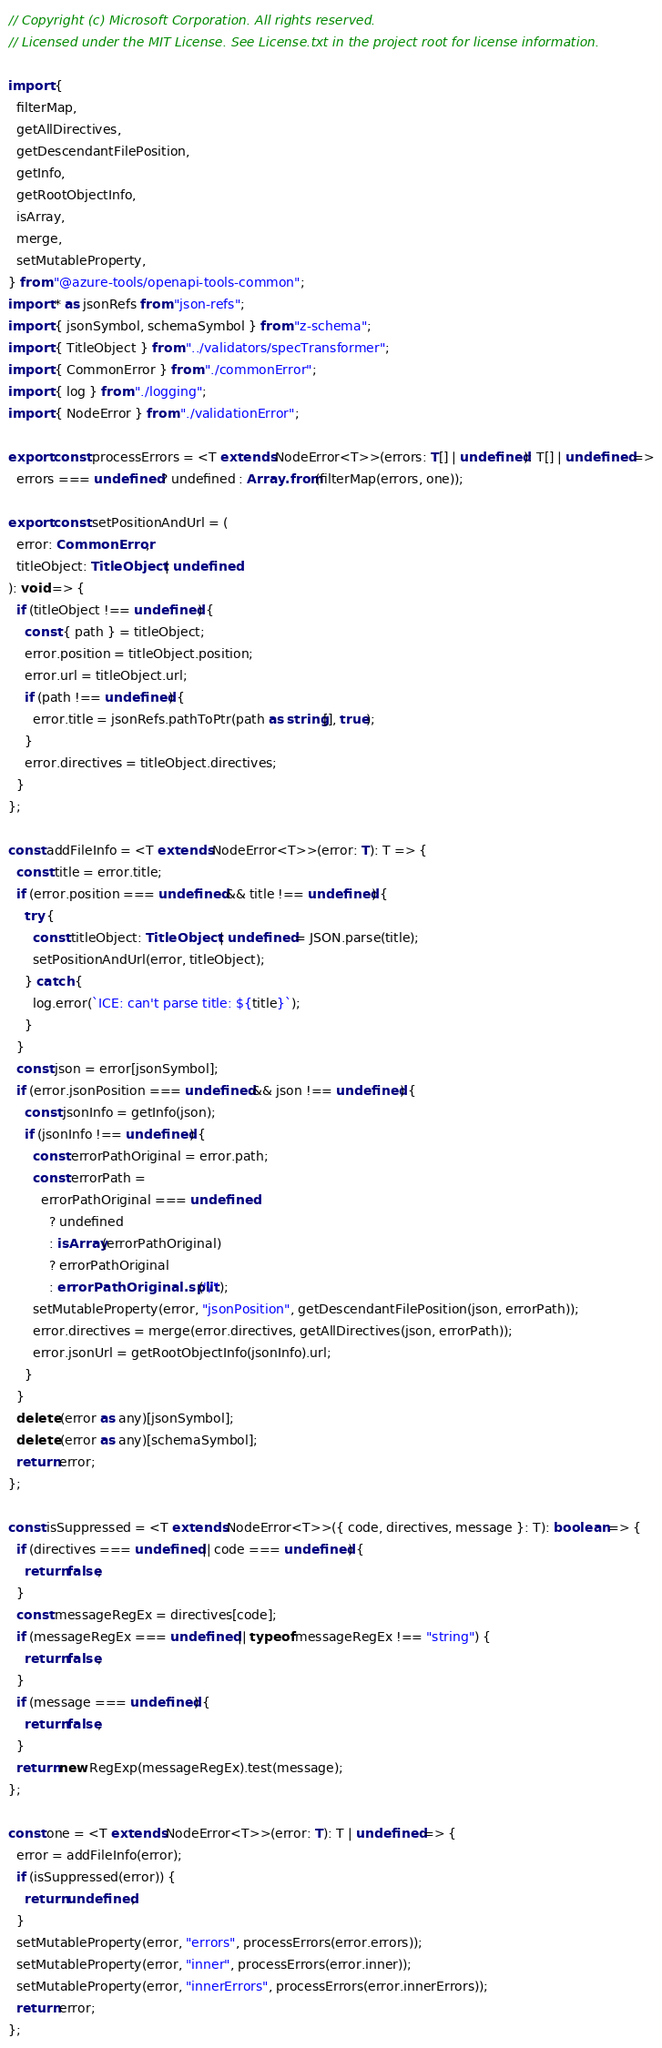<code> <loc_0><loc_0><loc_500><loc_500><_TypeScript_>// Copyright (c) Microsoft Corporation. All rights reserved.
// Licensed under the MIT License. See License.txt in the project root for license information.

import {
  filterMap,
  getAllDirectives,
  getDescendantFilePosition,
  getInfo,
  getRootObjectInfo,
  isArray,
  merge,
  setMutableProperty,
} from "@azure-tools/openapi-tools-common";
import * as jsonRefs from "json-refs";
import { jsonSymbol, schemaSymbol } from "z-schema";
import { TitleObject } from "../validators/specTransformer";
import { CommonError } from "./commonError";
import { log } from "./logging";
import { NodeError } from "./validationError";

export const processErrors = <T extends NodeError<T>>(errors: T[] | undefined): T[] | undefined =>
  errors === undefined ? undefined : Array.from(filterMap(errors, one));

export const setPositionAndUrl = (
  error: CommonError,
  titleObject: TitleObject | undefined
): void => {
  if (titleObject !== undefined) {
    const { path } = titleObject;
    error.position = titleObject.position;
    error.url = titleObject.url;
    if (path !== undefined) {
      error.title = jsonRefs.pathToPtr(path as string[], true);
    }
    error.directives = titleObject.directives;
  }
};

const addFileInfo = <T extends NodeError<T>>(error: T): T => {
  const title = error.title;
  if (error.position === undefined && title !== undefined) {
    try {
      const titleObject: TitleObject | undefined = JSON.parse(title);
      setPositionAndUrl(error, titleObject);
    } catch {
      log.error(`ICE: can't parse title: ${title}`);
    }
  }
  const json = error[jsonSymbol];
  if (error.jsonPosition === undefined && json !== undefined) {
    const jsonInfo = getInfo(json);
    if (jsonInfo !== undefined) {
      const errorPathOriginal = error.path;
      const errorPath =
        errorPathOriginal === undefined
          ? undefined
          : isArray(errorPathOriginal)
          ? errorPathOriginal
          : errorPathOriginal.split("/");
      setMutableProperty(error, "jsonPosition", getDescendantFilePosition(json, errorPath));
      error.directives = merge(error.directives, getAllDirectives(json, errorPath));
      error.jsonUrl = getRootObjectInfo(jsonInfo).url;
    }
  }
  delete (error as any)[jsonSymbol];
  delete (error as any)[schemaSymbol];
  return error;
};

const isSuppressed = <T extends NodeError<T>>({ code, directives, message }: T): boolean => {
  if (directives === undefined || code === undefined) {
    return false;
  }
  const messageRegEx = directives[code];
  if (messageRegEx === undefined || typeof messageRegEx !== "string") {
    return false;
  }
  if (message === undefined) {
    return false;
  }
  return new RegExp(messageRegEx).test(message);
};

const one = <T extends NodeError<T>>(error: T): T | undefined => {
  error = addFileInfo(error);
  if (isSuppressed(error)) {
    return undefined;
  }
  setMutableProperty(error, "errors", processErrors(error.errors));
  setMutableProperty(error, "inner", processErrors(error.inner));
  setMutableProperty(error, "innerErrors", processErrors(error.innerErrors));
  return error;
};
</code> 